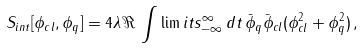<formula> <loc_0><loc_0><loc_500><loc_500>S _ { i n t } [ \phi _ { c l } , \phi _ { q } ] = 4 \lambda \, \Re \, \int \lim i t s _ { - \infty } ^ { \infty } \, d t \, \bar { \phi } _ { q } \bar { \phi } _ { c l } ( \phi _ { c l } ^ { 2 } + \phi _ { q } ^ { 2 } ) \, ,</formula> 